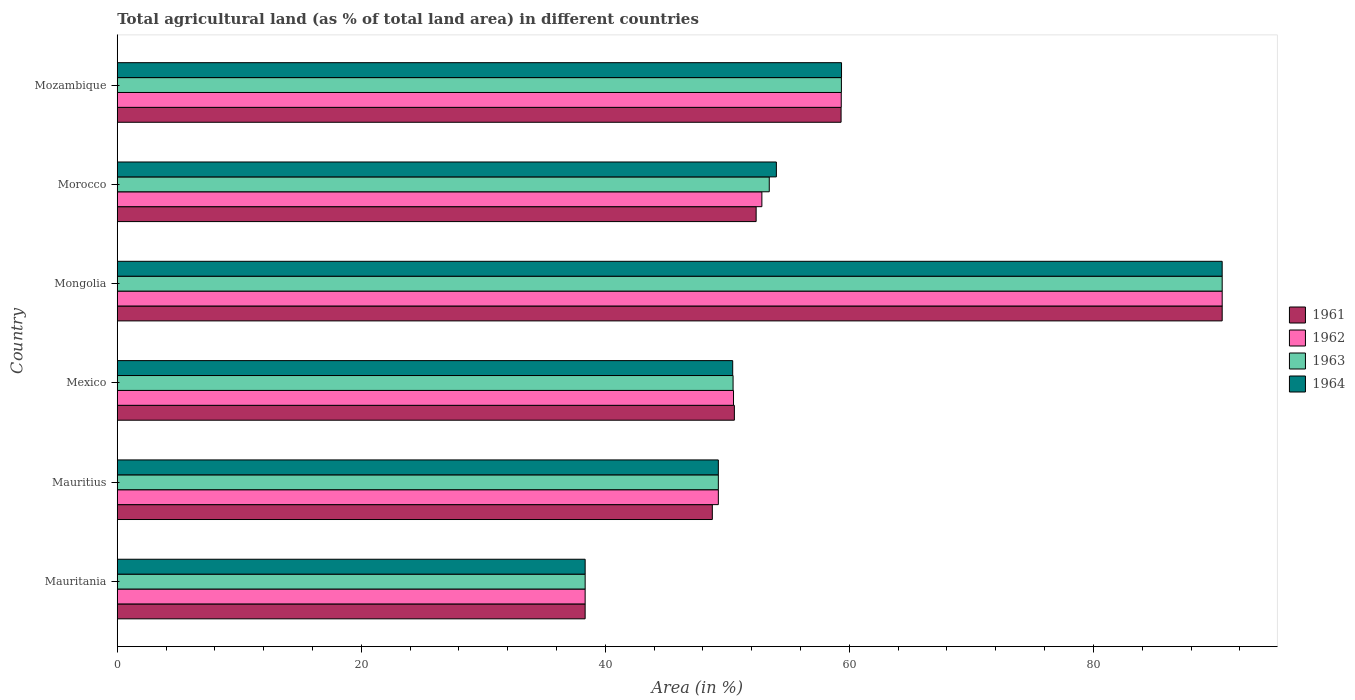Are the number of bars per tick equal to the number of legend labels?
Give a very brief answer. Yes. How many bars are there on the 4th tick from the top?
Give a very brief answer. 4. How many bars are there on the 1st tick from the bottom?
Make the answer very short. 4. What is the label of the 5th group of bars from the top?
Your answer should be very brief. Mauritius. What is the percentage of agricultural land in 1963 in Morocco?
Your answer should be very brief. 53.43. Across all countries, what is the maximum percentage of agricultural land in 1963?
Provide a succinct answer. 90.56. Across all countries, what is the minimum percentage of agricultural land in 1963?
Ensure brevity in your answer.  38.35. In which country was the percentage of agricultural land in 1962 maximum?
Provide a succinct answer. Mongolia. In which country was the percentage of agricultural land in 1962 minimum?
Your answer should be compact. Mauritania. What is the total percentage of agricultural land in 1961 in the graph?
Your answer should be very brief. 339.92. What is the difference between the percentage of agricultural land in 1961 in Mauritania and that in Morocco?
Make the answer very short. -14.01. What is the difference between the percentage of agricultural land in 1964 in Morocco and the percentage of agricultural land in 1963 in Mauritania?
Give a very brief answer. 15.67. What is the average percentage of agricultural land in 1964 per country?
Your answer should be very brief. 57. What is the difference between the percentage of agricultural land in 1963 and percentage of agricultural land in 1964 in Morocco?
Offer a very short reply. -0.58. In how many countries, is the percentage of agricultural land in 1963 greater than 24 %?
Provide a succinct answer. 6. What is the ratio of the percentage of agricultural land in 1963 in Mexico to that in Mongolia?
Keep it short and to the point. 0.56. Is the difference between the percentage of agricultural land in 1963 in Mauritania and Mozambique greater than the difference between the percentage of agricultural land in 1964 in Mauritania and Mozambique?
Make the answer very short. Yes. What is the difference between the highest and the second highest percentage of agricultural land in 1963?
Make the answer very short. 31.21. What is the difference between the highest and the lowest percentage of agricultural land in 1964?
Provide a short and direct response. 52.21. In how many countries, is the percentage of agricultural land in 1962 greater than the average percentage of agricultural land in 1962 taken over all countries?
Offer a very short reply. 2. Is the sum of the percentage of agricultural land in 1961 in Mauritania and Mexico greater than the maximum percentage of agricultural land in 1964 across all countries?
Offer a very short reply. No. Is it the case that in every country, the sum of the percentage of agricultural land in 1964 and percentage of agricultural land in 1963 is greater than the percentage of agricultural land in 1961?
Give a very brief answer. Yes. How many bars are there?
Your response must be concise. 24. How many countries are there in the graph?
Keep it short and to the point. 6. Are the values on the major ticks of X-axis written in scientific E-notation?
Give a very brief answer. No. Does the graph contain any zero values?
Ensure brevity in your answer.  No. Does the graph contain grids?
Provide a short and direct response. No. Where does the legend appear in the graph?
Your answer should be compact. Center right. How many legend labels are there?
Give a very brief answer. 4. What is the title of the graph?
Give a very brief answer. Total agricultural land (as % of total land area) in different countries. Does "1975" appear as one of the legend labels in the graph?
Offer a very short reply. No. What is the label or title of the X-axis?
Your answer should be very brief. Area (in %). What is the label or title of the Y-axis?
Give a very brief answer. Country. What is the Area (in %) of 1961 in Mauritania?
Keep it short and to the point. 38.34. What is the Area (in %) of 1962 in Mauritania?
Provide a short and direct response. 38.34. What is the Area (in %) in 1963 in Mauritania?
Offer a terse response. 38.35. What is the Area (in %) of 1964 in Mauritania?
Your answer should be very brief. 38.35. What is the Area (in %) in 1961 in Mauritius?
Make the answer very short. 48.77. What is the Area (in %) in 1962 in Mauritius?
Provide a short and direct response. 49.26. What is the Area (in %) of 1963 in Mauritius?
Provide a succinct answer. 49.26. What is the Area (in %) of 1964 in Mauritius?
Ensure brevity in your answer.  49.26. What is the Area (in %) in 1961 in Mexico?
Make the answer very short. 50.58. What is the Area (in %) of 1962 in Mexico?
Your answer should be compact. 50.5. What is the Area (in %) of 1963 in Mexico?
Keep it short and to the point. 50.47. What is the Area (in %) of 1964 in Mexico?
Offer a very short reply. 50.44. What is the Area (in %) of 1961 in Mongolia?
Give a very brief answer. 90.56. What is the Area (in %) of 1962 in Mongolia?
Ensure brevity in your answer.  90.56. What is the Area (in %) of 1963 in Mongolia?
Provide a succinct answer. 90.56. What is the Area (in %) in 1964 in Mongolia?
Your answer should be very brief. 90.55. What is the Area (in %) in 1961 in Morocco?
Keep it short and to the point. 52.36. What is the Area (in %) of 1962 in Morocco?
Give a very brief answer. 52.83. What is the Area (in %) in 1963 in Morocco?
Give a very brief answer. 53.43. What is the Area (in %) of 1964 in Morocco?
Provide a succinct answer. 54.02. What is the Area (in %) of 1961 in Mozambique?
Keep it short and to the point. 59.32. What is the Area (in %) of 1962 in Mozambique?
Keep it short and to the point. 59.34. What is the Area (in %) of 1963 in Mozambique?
Offer a very short reply. 59.35. What is the Area (in %) in 1964 in Mozambique?
Your answer should be compact. 59.36. Across all countries, what is the maximum Area (in %) of 1961?
Offer a very short reply. 90.56. Across all countries, what is the maximum Area (in %) of 1962?
Provide a succinct answer. 90.56. Across all countries, what is the maximum Area (in %) of 1963?
Your answer should be compact. 90.56. Across all countries, what is the maximum Area (in %) of 1964?
Give a very brief answer. 90.55. Across all countries, what is the minimum Area (in %) of 1961?
Keep it short and to the point. 38.34. Across all countries, what is the minimum Area (in %) of 1962?
Give a very brief answer. 38.34. Across all countries, what is the minimum Area (in %) in 1963?
Offer a terse response. 38.35. Across all countries, what is the minimum Area (in %) in 1964?
Make the answer very short. 38.35. What is the total Area (in %) of 1961 in the graph?
Make the answer very short. 339.92. What is the total Area (in %) of 1962 in the graph?
Provide a short and direct response. 340.83. What is the total Area (in %) of 1963 in the graph?
Give a very brief answer. 341.41. What is the total Area (in %) in 1964 in the graph?
Offer a very short reply. 341.97. What is the difference between the Area (in %) in 1961 in Mauritania and that in Mauritius?
Make the answer very short. -10.42. What is the difference between the Area (in %) of 1962 in Mauritania and that in Mauritius?
Your answer should be compact. -10.92. What is the difference between the Area (in %) in 1963 in Mauritania and that in Mauritius?
Your answer should be very brief. -10.92. What is the difference between the Area (in %) in 1964 in Mauritania and that in Mauritius?
Your answer should be compact. -10.92. What is the difference between the Area (in %) in 1961 in Mauritania and that in Mexico?
Provide a short and direct response. -12.23. What is the difference between the Area (in %) in 1962 in Mauritania and that in Mexico?
Give a very brief answer. -12.16. What is the difference between the Area (in %) of 1963 in Mauritania and that in Mexico?
Provide a succinct answer. -12.12. What is the difference between the Area (in %) in 1964 in Mauritania and that in Mexico?
Your answer should be compact. -12.09. What is the difference between the Area (in %) of 1961 in Mauritania and that in Mongolia?
Give a very brief answer. -52.21. What is the difference between the Area (in %) in 1962 in Mauritania and that in Mongolia?
Your answer should be compact. -52.21. What is the difference between the Area (in %) in 1963 in Mauritania and that in Mongolia?
Offer a terse response. -52.21. What is the difference between the Area (in %) in 1964 in Mauritania and that in Mongolia?
Your answer should be compact. -52.21. What is the difference between the Area (in %) of 1961 in Mauritania and that in Morocco?
Provide a succinct answer. -14.01. What is the difference between the Area (in %) in 1962 in Mauritania and that in Morocco?
Provide a succinct answer. -14.48. What is the difference between the Area (in %) in 1963 in Mauritania and that in Morocco?
Keep it short and to the point. -15.09. What is the difference between the Area (in %) of 1964 in Mauritania and that in Morocco?
Your response must be concise. -15.67. What is the difference between the Area (in %) in 1961 in Mauritania and that in Mozambique?
Your answer should be very brief. -20.98. What is the difference between the Area (in %) in 1962 in Mauritania and that in Mozambique?
Make the answer very short. -20.99. What is the difference between the Area (in %) in 1963 in Mauritania and that in Mozambique?
Provide a succinct answer. -21. What is the difference between the Area (in %) of 1964 in Mauritania and that in Mozambique?
Make the answer very short. -21.01. What is the difference between the Area (in %) of 1961 in Mauritius and that in Mexico?
Your response must be concise. -1.81. What is the difference between the Area (in %) in 1962 in Mauritius and that in Mexico?
Ensure brevity in your answer.  -1.24. What is the difference between the Area (in %) of 1963 in Mauritius and that in Mexico?
Offer a very short reply. -1.21. What is the difference between the Area (in %) of 1964 in Mauritius and that in Mexico?
Provide a short and direct response. -1.18. What is the difference between the Area (in %) of 1961 in Mauritius and that in Mongolia?
Provide a succinct answer. -41.79. What is the difference between the Area (in %) in 1962 in Mauritius and that in Mongolia?
Provide a succinct answer. -41.29. What is the difference between the Area (in %) in 1963 in Mauritius and that in Mongolia?
Your response must be concise. -41.29. What is the difference between the Area (in %) of 1964 in Mauritius and that in Mongolia?
Ensure brevity in your answer.  -41.29. What is the difference between the Area (in %) of 1961 in Mauritius and that in Morocco?
Offer a terse response. -3.59. What is the difference between the Area (in %) in 1962 in Mauritius and that in Morocco?
Your answer should be compact. -3.57. What is the difference between the Area (in %) in 1963 in Mauritius and that in Morocco?
Offer a very short reply. -4.17. What is the difference between the Area (in %) in 1964 in Mauritius and that in Morocco?
Ensure brevity in your answer.  -4.76. What is the difference between the Area (in %) in 1961 in Mauritius and that in Mozambique?
Offer a very short reply. -10.55. What is the difference between the Area (in %) of 1962 in Mauritius and that in Mozambique?
Your response must be concise. -10.07. What is the difference between the Area (in %) in 1963 in Mauritius and that in Mozambique?
Your answer should be very brief. -10.09. What is the difference between the Area (in %) of 1964 in Mauritius and that in Mozambique?
Ensure brevity in your answer.  -10.1. What is the difference between the Area (in %) in 1961 in Mexico and that in Mongolia?
Make the answer very short. -39.98. What is the difference between the Area (in %) in 1962 in Mexico and that in Mongolia?
Provide a short and direct response. -40.05. What is the difference between the Area (in %) in 1963 in Mexico and that in Mongolia?
Provide a short and direct response. -40.09. What is the difference between the Area (in %) of 1964 in Mexico and that in Mongolia?
Your answer should be very brief. -40.12. What is the difference between the Area (in %) of 1961 in Mexico and that in Morocco?
Provide a succinct answer. -1.78. What is the difference between the Area (in %) in 1962 in Mexico and that in Morocco?
Your answer should be compact. -2.32. What is the difference between the Area (in %) of 1963 in Mexico and that in Morocco?
Make the answer very short. -2.97. What is the difference between the Area (in %) of 1964 in Mexico and that in Morocco?
Offer a very short reply. -3.58. What is the difference between the Area (in %) in 1961 in Mexico and that in Mozambique?
Offer a terse response. -8.75. What is the difference between the Area (in %) in 1962 in Mexico and that in Mozambique?
Provide a short and direct response. -8.83. What is the difference between the Area (in %) in 1963 in Mexico and that in Mozambique?
Ensure brevity in your answer.  -8.88. What is the difference between the Area (in %) in 1964 in Mexico and that in Mozambique?
Make the answer very short. -8.92. What is the difference between the Area (in %) of 1961 in Mongolia and that in Morocco?
Your response must be concise. 38.2. What is the difference between the Area (in %) of 1962 in Mongolia and that in Morocco?
Your answer should be very brief. 37.73. What is the difference between the Area (in %) in 1963 in Mongolia and that in Morocco?
Give a very brief answer. 37.12. What is the difference between the Area (in %) of 1964 in Mongolia and that in Morocco?
Ensure brevity in your answer.  36.54. What is the difference between the Area (in %) of 1961 in Mongolia and that in Mozambique?
Your answer should be very brief. 31.23. What is the difference between the Area (in %) in 1962 in Mongolia and that in Mozambique?
Give a very brief answer. 31.22. What is the difference between the Area (in %) in 1963 in Mongolia and that in Mozambique?
Your answer should be compact. 31.21. What is the difference between the Area (in %) in 1964 in Mongolia and that in Mozambique?
Offer a very short reply. 31.2. What is the difference between the Area (in %) in 1961 in Morocco and that in Mozambique?
Offer a very short reply. -6.96. What is the difference between the Area (in %) of 1962 in Morocco and that in Mozambique?
Your answer should be very brief. -6.51. What is the difference between the Area (in %) in 1963 in Morocco and that in Mozambique?
Provide a short and direct response. -5.91. What is the difference between the Area (in %) in 1964 in Morocco and that in Mozambique?
Your answer should be very brief. -5.34. What is the difference between the Area (in %) of 1961 in Mauritania and the Area (in %) of 1962 in Mauritius?
Keep it short and to the point. -10.92. What is the difference between the Area (in %) of 1961 in Mauritania and the Area (in %) of 1963 in Mauritius?
Offer a terse response. -10.92. What is the difference between the Area (in %) of 1961 in Mauritania and the Area (in %) of 1964 in Mauritius?
Provide a succinct answer. -10.92. What is the difference between the Area (in %) in 1962 in Mauritania and the Area (in %) in 1963 in Mauritius?
Keep it short and to the point. -10.92. What is the difference between the Area (in %) in 1962 in Mauritania and the Area (in %) in 1964 in Mauritius?
Provide a short and direct response. -10.92. What is the difference between the Area (in %) in 1963 in Mauritania and the Area (in %) in 1964 in Mauritius?
Provide a succinct answer. -10.92. What is the difference between the Area (in %) of 1961 in Mauritania and the Area (in %) of 1962 in Mexico?
Ensure brevity in your answer.  -12.16. What is the difference between the Area (in %) in 1961 in Mauritania and the Area (in %) in 1963 in Mexico?
Keep it short and to the point. -12.12. What is the difference between the Area (in %) of 1961 in Mauritania and the Area (in %) of 1964 in Mexico?
Make the answer very short. -12.09. What is the difference between the Area (in %) in 1962 in Mauritania and the Area (in %) in 1963 in Mexico?
Ensure brevity in your answer.  -12.12. What is the difference between the Area (in %) in 1962 in Mauritania and the Area (in %) in 1964 in Mexico?
Your answer should be compact. -12.09. What is the difference between the Area (in %) in 1963 in Mauritania and the Area (in %) in 1964 in Mexico?
Your response must be concise. -12.09. What is the difference between the Area (in %) in 1961 in Mauritania and the Area (in %) in 1962 in Mongolia?
Your answer should be compact. -52.21. What is the difference between the Area (in %) in 1961 in Mauritania and the Area (in %) in 1963 in Mongolia?
Your answer should be very brief. -52.21. What is the difference between the Area (in %) of 1961 in Mauritania and the Area (in %) of 1964 in Mongolia?
Provide a succinct answer. -52.21. What is the difference between the Area (in %) of 1962 in Mauritania and the Area (in %) of 1963 in Mongolia?
Ensure brevity in your answer.  -52.21. What is the difference between the Area (in %) of 1962 in Mauritania and the Area (in %) of 1964 in Mongolia?
Offer a terse response. -52.21. What is the difference between the Area (in %) in 1963 in Mauritania and the Area (in %) in 1964 in Mongolia?
Your response must be concise. -52.21. What is the difference between the Area (in %) of 1961 in Mauritania and the Area (in %) of 1962 in Morocco?
Provide a succinct answer. -14.48. What is the difference between the Area (in %) in 1961 in Mauritania and the Area (in %) in 1963 in Morocco?
Give a very brief answer. -15.09. What is the difference between the Area (in %) in 1961 in Mauritania and the Area (in %) in 1964 in Morocco?
Provide a short and direct response. -15.67. What is the difference between the Area (in %) in 1962 in Mauritania and the Area (in %) in 1963 in Morocco?
Your answer should be compact. -15.09. What is the difference between the Area (in %) in 1962 in Mauritania and the Area (in %) in 1964 in Morocco?
Your answer should be very brief. -15.67. What is the difference between the Area (in %) of 1963 in Mauritania and the Area (in %) of 1964 in Morocco?
Keep it short and to the point. -15.67. What is the difference between the Area (in %) in 1961 in Mauritania and the Area (in %) in 1962 in Mozambique?
Give a very brief answer. -20.99. What is the difference between the Area (in %) of 1961 in Mauritania and the Area (in %) of 1963 in Mozambique?
Offer a very short reply. -21. What is the difference between the Area (in %) in 1961 in Mauritania and the Area (in %) in 1964 in Mozambique?
Make the answer very short. -21.01. What is the difference between the Area (in %) of 1962 in Mauritania and the Area (in %) of 1963 in Mozambique?
Ensure brevity in your answer.  -21. What is the difference between the Area (in %) of 1962 in Mauritania and the Area (in %) of 1964 in Mozambique?
Ensure brevity in your answer.  -21.01. What is the difference between the Area (in %) in 1963 in Mauritania and the Area (in %) in 1964 in Mozambique?
Provide a succinct answer. -21.01. What is the difference between the Area (in %) in 1961 in Mauritius and the Area (in %) in 1962 in Mexico?
Ensure brevity in your answer.  -1.74. What is the difference between the Area (in %) in 1961 in Mauritius and the Area (in %) in 1963 in Mexico?
Your answer should be compact. -1.7. What is the difference between the Area (in %) in 1961 in Mauritius and the Area (in %) in 1964 in Mexico?
Your answer should be very brief. -1.67. What is the difference between the Area (in %) in 1962 in Mauritius and the Area (in %) in 1963 in Mexico?
Keep it short and to the point. -1.21. What is the difference between the Area (in %) of 1962 in Mauritius and the Area (in %) of 1964 in Mexico?
Provide a short and direct response. -1.18. What is the difference between the Area (in %) of 1963 in Mauritius and the Area (in %) of 1964 in Mexico?
Your answer should be compact. -1.18. What is the difference between the Area (in %) in 1961 in Mauritius and the Area (in %) in 1962 in Mongolia?
Offer a very short reply. -41.79. What is the difference between the Area (in %) in 1961 in Mauritius and the Area (in %) in 1963 in Mongolia?
Provide a succinct answer. -41.79. What is the difference between the Area (in %) of 1961 in Mauritius and the Area (in %) of 1964 in Mongolia?
Your response must be concise. -41.79. What is the difference between the Area (in %) in 1962 in Mauritius and the Area (in %) in 1963 in Mongolia?
Your answer should be very brief. -41.29. What is the difference between the Area (in %) of 1962 in Mauritius and the Area (in %) of 1964 in Mongolia?
Your response must be concise. -41.29. What is the difference between the Area (in %) in 1963 in Mauritius and the Area (in %) in 1964 in Mongolia?
Ensure brevity in your answer.  -41.29. What is the difference between the Area (in %) of 1961 in Mauritius and the Area (in %) of 1962 in Morocco?
Provide a short and direct response. -4.06. What is the difference between the Area (in %) of 1961 in Mauritius and the Area (in %) of 1963 in Morocco?
Make the answer very short. -4.67. What is the difference between the Area (in %) of 1961 in Mauritius and the Area (in %) of 1964 in Morocco?
Keep it short and to the point. -5.25. What is the difference between the Area (in %) of 1962 in Mauritius and the Area (in %) of 1963 in Morocco?
Provide a short and direct response. -4.17. What is the difference between the Area (in %) of 1962 in Mauritius and the Area (in %) of 1964 in Morocco?
Your answer should be compact. -4.76. What is the difference between the Area (in %) in 1963 in Mauritius and the Area (in %) in 1964 in Morocco?
Make the answer very short. -4.76. What is the difference between the Area (in %) in 1961 in Mauritius and the Area (in %) in 1962 in Mozambique?
Keep it short and to the point. -10.57. What is the difference between the Area (in %) in 1961 in Mauritius and the Area (in %) in 1963 in Mozambique?
Provide a short and direct response. -10.58. What is the difference between the Area (in %) of 1961 in Mauritius and the Area (in %) of 1964 in Mozambique?
Keep it short and to the point. -10.59. What is the difference between the Area (in %) in 1962 in Mauritius and the Area (in %) in 1963 in Mozambique?
Your response must be concise. -10.09. What is the difference between the Area (in %) of 1962 in Mauritius and the Area (in %) of 1964 in Mozambique?
Provide a short and direct response. -10.1. What is the difference between the Area (in %) of 1963 in Mauritius and the Area (in %) of 1964 in Mozambique?
Your answer should be compact. -10.1. What is the difference between the Area (in %) of 1961 in Mexico and the Area (in %) of 1962 in Mongolia?
Make the answer very short. -39.98. What is the difference between the Area (in %) in 1961 in Mexico and the Area (in %) in 1963 in Mongolia?
Offer a very short reply. -39.98. What is the difference between the Area (in %) in 1961 in Mexico and the Area (in %) in 1964 in Mongolia?
Make the answer very short. -39.98. What is the difference between the Area (in %) of 1962 in Mexico and the Area (in %) of 1963 in Mongolia?
Offer a very short reply. -40.05. What is the difference between the Area (in %) of 1962 in Mexico and the Area (in %) of 1964 in Mongolia?
Your answer should be very brief. -40.05. What is the difference between the Area (in %) in 1963 in Mexico and the Area (in %) in 1964 in Mongolia?
Your answer should be very brief. -40.09. What is the difference between the Area (in %) in 1961 in Mexico and the Area (in %) in 1962 in Morocco?
Provide a succinct answer. -2.25. What is the difference between the Area (in %) of 1961 in Mexico and the Area (in %) of 1963 in Morocco?
Your answer should be very brief. -2.86. What is the difference between the Area (in %) in 1961 in Mexico and the Area (in %) in 1964 in Morocco?
Keep it short and to the point. -3.44. What is the difference between the Area (in %) in 1962 in Mexico and the Area (in %) in 1963 in Morocco?
Make the answer very short. -2.93. What is the difference between the Area (in %) of 1962 in Mexico and the Area (in %) of 1964 in Morocco?
Make the answer very short. -3.51. What is the difference between the Area (in %) in 1963 in Mexico and the Area (in %) in 1964 in Morocco?
Provide a succinct answer. -3.55. What is the difference between the Area (in %) of 1961 in Mexico and the Area (in %) of 1962 in Mozambique?
Give a very brief answer. -8.76. What is the difference between the Area (in %) of 1961 in Mexico and the Area (in %) of 1963 in Mozambique?
Your answer should be very brief. -8.77. What is the difference between the Area (in %) of 1961 in Mexico and the Area (in %) of 1964 in Mozambique?
Make the answer very short. -8.78. What is the difference between the Area (in %) in 1962 in Mexico and the Area (in %) in 1963 in Mozambique?
Offer a terse response. -8.84. What is the difference between the Area (in %) of 1962 in Mexico and the Area (in %) of 1964 in Mozambique?
Ensure brevity in your answer.  -8.85. What is the difference between the Area (in %) in 1963 in Mexico and the Area (in %) in 1964 in Mozambique?
Give a very brief answer. -8.89. What is the difference between the Area (in %) of 1961 in Mongolia and the Area (in %) of 1962 in Morocco?
Make the answer very short. 37.73. What is the difference between the Area (in %) of 1961 in Mongolia and the Area (in %) of 1963 in Morocco?
Your answer should be compact. 37.12. What is the difference between the Area (in %) in 1961 in Mongolia and the Area (in %) in 1964 in Morocco?
Make the answer very short. 36.54. What is the difference between the Area (in %) of 1962 in Mongolia and the Area (in %) of 1963 in Morocco?
Keep it short and to the point. 37.12. What is the difference between the Area (in %) of 1962 in Mongolia and the Area (in %) of 1964 in Morocco?
Offer a very short reply. 36.54. What is the difference between the Area (in %) in 1963 in Mongolia and the Area (in %) in 1964 in Morocco?
Your answer should be very brief. 36.54. What is the difference between the Area (in %) in 1961 in Mongolia and the Area (in %) in 1962 in Mozambique?
Keep it short and to the point. 31.22. What is the difference between the Area (in %) of 1961 in Mongolia and the Area (in %) of 1963 in Mozambique?
Give a very brief answer. 31.21. What is the difference between the Area (in %) of 1961 in Mongolia and the Area (in %) of 1964 in Mozambique?
Offer a terse response. 31.2. What is the difference between the Area (in %) in 1962 in Mongolia and the Area (in %) in 1963 in Mozambique?
Give a very brief answer. 31.21. What is the difference between the Area (in %) of 1962 in Mongolia and the Area (in %) of 1964 in Mozambique?
Ensure brevity in your answer.  31.2. What is the difference between the Area (in %) of 1963 in Mongolia and the Area (in %) of 1964 in Mozambique?
Provide a short and direct response. 31.2. What is the difference between the Area (in %) in 1961 in Morocco and the Area (in %) in 1962 in Mozambique?
Provide a succinct answer. -6.98. What is the difference between the Area (in %) of 1961 in Morocco and the Area (in %) of 1963 in Mozambique?
Offer a terse response. -6.99. What is the difference between the Area (in %) of 1961 in Morocco and the Area (in %) of 1964 in Mozambique?
Your answer should be very brief. -7. What is the difference between the Area (in %) in 1962 in Morocco and the Area (in %) in 1963 in Mozambique?
Offer a terse response. -6.52. What is the difference between the Area (in %) of 1962 in Morocco and the Area (in %) of 1964 in Mozambique?
Give a very brief answer. -6.53. What is the difference between the Area (in %) in 1963 in Morocco and the Area (in %) in 1964 in Mozambique?
Keep it short and to the point. -5.92. What is the average Area (in %) in 1961 per country?
Give a very brief answer. 56.65. What is the average Area (in %) in 1962 per country?
Provide a succinct answer. 56.81. What is the average Area (in %) of 1963 per country?
Keep it short and to the point. 56.9. What is the average Area (in %) of 1964 per country?
Offer a terse response. 57. What is the difference between the Area (in %) of 1961 and Area (in %) of 1962 in Mauritania?
Make the answer very short. 0. What is the difference between the Area (in %) of 1961 and Area (in %) of 1963 in Mauritania?
Keep it short and to the point. -0. What is the difference between the Area (in %) in 1961 and Area (in %) in 1964 in Mauritania?
Offer a very short reply. -0. What is the difference between the Area (in %) of 1962 and Area (in %) of 1963 in Mauritania?
Your answer should be compact. -0. What is the difference between the Area (in %) of 1962 and Area (in %) of 1964 in Mauritania?
Ensure brevity in your answer.  -0. What is the difference between the Area (in %) in 1961 and Area (in %) in 1962 in Mauritius?
Make the answer very short. -0.49. What is the difference between the Area (in %) of 1961 and Area (in %) of 1963 in Mauritius?
Offer a terse response. -0.49. What is the difference between the Area (in %) of 1961 and Area (in %) of 1964 in Mauritius?
Keep it short and to the point. -0.49. What is the difference between the Area (in %) in 1963 and Area (in %) in 1964 in Mauritius?
Your answer should be compact. 0. What is the difference between the Area (in %) in 1961 and Area (in %) in 1962 in Mexico?
Offer a terse response. 0.07. What is the difference between the Area (in %) in 1961 and Area (in %) in 1963 in Mexico?
Make the answer very short. 0.11. What is the difference between the Area (in %) in 1961 and Area (in %) in 1964 in Mexico?
Your response must be concise. 0.14. What is the difference between the Area (in %) in 1962 and Area (in %) in 1963 in Mexico?
Provide a succinct answer. 0.04. What is the difference between the Area (in %) of 1962 and Area (in %) of 1964 in Mexico?
Keep it short and to the point. 0.07. What is the difference between the Area (in %) in 1963 and Area (in %) in 1964 in Mexico?
Offer a very short reply. 0.03. What is the difference between the Area (in %) in 1961 and Area (in %) in 1962 in Mongolia?
Provide a succinct answer. 0. What is the difference between the Area (in %) of 1961 and Area (in %) of 1963 in Mongolia?
Make the answer very short. 0. What is the difference between the Area (in %) of 1961 and Area (in %) of 1964 in Mongolia?
Provide a short and direct response. 0. What is the difference between the Area (in %) in 1962 and Area (in %) in 1963 in Mongolia?
Make the answer very short. 0. What is the difference between the Area (in %) in 1962 and Area (in %) in 1964 in Mongolia?
Your response must be concise. 0. What is the difference between the Area (in %) of 1963 and Area (in %) of 1964 in Mongolia?
Keep it short and to the point. 0. What is the difference between the Area (in %) in 1961 and Area (in %) in 1962 in Morocco?
Offer a terse response. -0.47. What is the difference between the Area (in %) of 1961 and Area (in %) of 1963 in Morocco?
Your answer should be compact. -1.08. What is the difference between the Area (in %) in 1961 and Area (in %) in 1964 in Morocco?
Offer a very short reply. -1.66. What is the difference between the Area (in %) of 1962 and Area (in %) of 1963 in Morocco?
Your answer should be compact. -0.6. What is the difference between the Area (in %) in 1962 and Area (in %) in 1964 in Morocco?
Offer a very short reply. -1.19. What is the difference between the Area (in %) in 1963 and Area (in %) in 1964 in Morocco?
Make the answer very short. -0.58. What is the difference between the Area (in %) in 1961 and Area (in %) in 1962 in Mozambique?
Your answer should be very brief. -0.01. What is the difference between the Area (in %) in 1961 and Area (in %) in 1963 in Mozambique?
Offer a terse response. -0.03. What is the difference between the Area (in %) of 1961 and Area (in %) of 1964 in Mozambique?
Your answer should be very brief. -0.04. What is the difference between the Area (in %) of 1962 and Area (in %) of 1963 in Mozambique?
Keep it short and to the point. -0.01. What is the difference between the Area (in %) of 1962 and Area (in %) of 1964 in Mozambique?
Keep it short and to the point. -0.02. What is the difference between the Area (in %) in 1963 and Area (in %) in 1964 in Mozambique?
Offer a very short reply. -0.01. What is the ratio of the Area (in %) in 1961 in Mauritania to that in Mauritius?
Ensure brevity in your answer.  0.79. What is the ratio of the Area (in %) of 1962 in Mauritania to that in Mauritius?
Ensure brevity in your answer.  0.78. What is the ratio of the Area (in %) of 1963 in Mauritania to that in Mauritius?
Your response must be concise. 0.78. What is the ratio of the Area (in %) of 1964 in Mauritania to that in Mauritius?
Ensure brevity in your answer.  0.78. What is the ratio of the Area (in %) of 1961 in Mauritania to that in Mexico?
Your answer should be compact. 0.76. What is the ratio of the Area (in %) of 1962 in Mauritania to that in Mexico?
Offer a terse response. 0.76. What is the ratio of the Area (in %) in 1963 in Mauritania to that in Mexico?
Offer a very short reply. 0.76. What is the ratio of the Area (in %) in 1964 in Mauritania to that in Mexico?
Keep it short and to the point. 0.76. What is the ratio of the Area (in %) of 1961 in Mauritania to that in Mongolia?
Offer a very short reply. 0.42. What is the ratio of the Area (in %) of 1962 in Mauritania to that in Mongolia?
Provide a short and direct response. 0.42. What is the ratio of the Area (in %) of 1963 in Mauritania to that in Mongolia?
Provide a succinct answer. 0.42. What is the ratio of the Area (in %) of 1964 in Mauritania to that in Mongolia?
Ensure brevity in your answer.  0.42. What is the ratio of the Area (in %) of 1961 in Mauritania to that in Morocco?
Your answer should be compact. 0.73. What is the ratio of the Area (in %) in 1962 in Mauritania to that in Morocco?
Give a very brief answer. 0.73. What is the ratio of the Area (in %) in 1963 in Mauritania to that in Morocco?
Your response must be concise. 0.72. What is the ratio of the Area (in %) in 1964 in Mauritania to that in Morocco?
Provide a succinct answer. 0.71. What is the ratio of the Area (in %) of 1961 in Mauritania to that in Mozambique?
Make the answer very short. 0.65. What is the ratio of the Area (in %) in 1962 in Mauritania to that in Mozambique?
Your response must be concise. 0.65. What is the ratio of the Area (in %) in 1963 in Mauritania to that in Mozambique?
Provide a short and direct response. 0.65. What is the ratio of the Area (in %) of 1964 in Mauritania to that in Mozambique?
Your answer should be very brief. 0.65. What is the ratio of the Area (in %) of 1962 in Mauritius to that in Mexico?
Keep it short and to the point. 0.98. What is the ratio of the Area (in %) in 1963 in Mauritius to that in Mexico?
Offer a terse response. 0.98. What is the ratio of the Area (in %) in 1964 in Mauritius to that in Mexico?
Give a very brief answer. 0.98. What is the ratio of the Area (in %) in 1961 in Mauritius to that in Mongolia?
Provide a succinct answer. 0.54. What is the ratio of the Area (in %) in 1962 in Mauritius to that in Mongolia?
Provide a succinct answer. 0.54. What is the ratio of the Area (in %) of 1963 in Mauritius to that in Mongolia?
Make the answer very short. 0.54. What is the ratio of the Area (in %) in 1964 in Mauritius to that in Mongolia?
Your answer should be compact. 0.54. What is the ratio of the Area (in %) of 1961 in Mauritius to that in Morocco?
Offer a terse response. 0.93. What is the ratio of the Area (in %) of 1962 in Mauritius to that in Morocco?
Your answer should be very brief. 0.93. What is the ratio of the Area (in %) of 1963 in Mauritius to that in Morocco?
Provide a short and direct response. 0.92. What is the ratio of the Area (in %) of 1964 in Mauritius to that in Morocco?
Provide a short and direct response. 0.91. What is the ratio of the Area (in %) in 1961 in Mauritius to that in Mozambique?
Keep it short and to the point. 0.82. What is the ratio of the Area (in %) of 1962 in Mauritius to that in Mozambique?
Keep it short and to the point. 0.83. What is the ratio of the Area (in %) in 1963 in Mauritius to that in Mozambique?
Your answer should be very brief. 0.83. What is the ratio of the Area (in %) in 1964 in Mauritius to that in Mozambique?
Offer a very short reply. 0.83. What is the ratio of the Area (in %) in 1961 in Mexico to that in Mongolia?
Give a very brief answer. 0.56. What is the ratio of the Area (in %) of 1962 in Mexico to that in Mongolia?
Give a very brief answer. 0.56. What is the ratio of the Area (in %) of 1963 in Mexico to that in Mongolia?
Your answer should be compact. 0.56. What is the ratio of the Area (in %) of 1964 in Mexico to that in Mongolia?
Provide a short and direct response. 0.56. What is the ratio of the Area (in %) in 1961 in Mexico to that in Morocco?
Give a very brief answer. 0.97. What is the ratio of the Area (in %) of 1962 in Mexico to that in Morocco?
Your answer should be compact. 0.96. What is the ratio of the Area (in %) of 1963 in Mexico to that in Morocco?
Provide a short and direct response. 0.94. What is the ratio of the Area (in %) of 1964 in Mexico to that in Morocco?
Keep it short and to the point. 0.93. What is the ratio of the Area (in %) of 1961 in Mexico to that in Mozambique?
Your answer should be compact. 0.85. What is the ratio of the Area (in %) of 1962 in Mexico to that in Mozambique?
Make the answer very short. 0.85. What is the ratio of the Area (in %) in 1963 in Mexico to that in Mozambique?
Ensure brevity in your answer.  0.85. What is the ratio of the Area (in %) in 1964 in Mexico to that in Mozambique?
Offer a very short reply. 0.85. What is the ratio of the Area (in %) of 1961 in Mongolia to that in Morocco?
Your answer should be compact. 1.73. What is the ratio of the Area (in %) of 1962 in Mongolia to that in Morocco?
Give a very brief answer. 1.71. What is the ratio of the Area (in %) in 1963 in Mongolia to that in Morocco?
Provide a succinct answer. 1.69. What is the ratio of the Area (in %) in 1964 in Mongolia to that in Morocco?
Make the answer very short. 1.68. What is the ratio of the Area (in %) of 1961 in Mongolia to that in Mozambique?
Give a very brief answer. 1.53. What is the ratio of the Area (in %) in 1962 in Mongolia to that in Mozambique?
Provide a succinct answer. 1.53. What is the ratio of the Area (in %) in 1963 in Mongolia to that in Mozambique?
Your response must be concise. 1.53. What is the ratio of the Area (in %) in 1964 in Mongolia to that in Mozambique?
Your response must be concise. 1.53. What is the ratio of the Area (in %) in 1961 in Morocco to that in Mozambique?
Your response must be concise. 0.88. What is the ratio of the Area (in %) of 1962 in Morocco to that in Mozambique?
Offer a terse response. 0.89. What is the ratio of the Area (in %) of 1963 in Morocco to that in Mozambique?
Your answer should be compact. 0.9. What is the ratio of the Area (in %) of 1964 in Morocco to that in Mozambique?
Your response must be concise. 0.91. What is the difference between the highest and the second highest Area (in %) of 1961?
Ensure brevity in your answer.  31.23. What is the difference between the highest and the second highest Area (in %) in 1962?
Offer a terse response. 31.22. What is the difference between the highest and the second highest Area (in %) of 1963?
Your answer should be compact. 31.21. What is the difference between the highest and the second highest Area (in %) in 1964?
Your response must be concise. 31.2. What is the difference between the highest and the lowest Area (in %) in 1961?
Provide a succinct answer. 52.21. What is the difference between the highest and the lowest Area (in %) in 1962?
Keep it short and to the point. 52.21. What is the difference between the highest and the lowest Area (in %) of 1963?
Ensure brevity in your answer.  52.21. What is the difference between the highest and the lowest Area (in %) of 1964?
Keep it short and to the point. 52.21. 